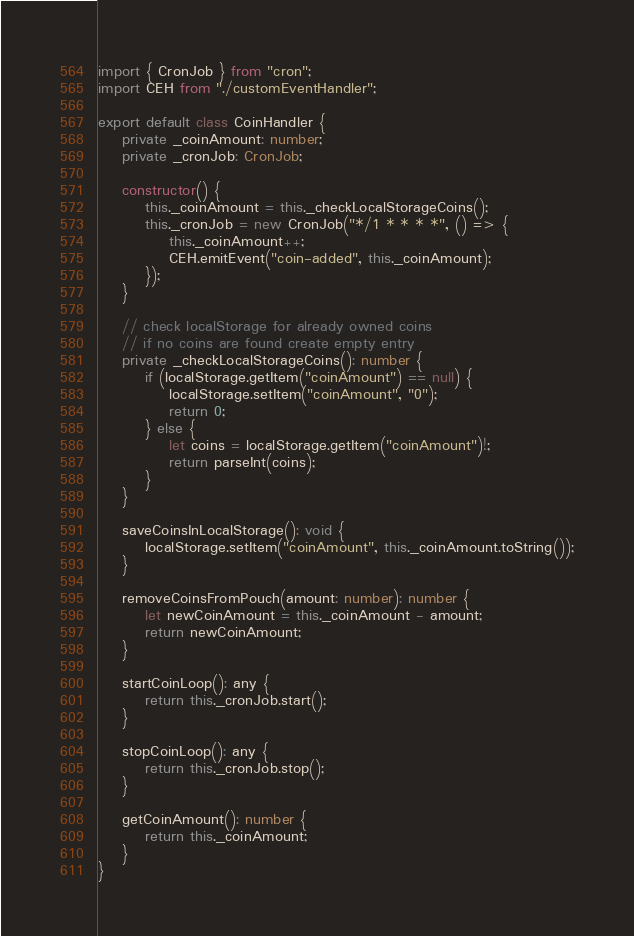<code> <loc_0><loc_0><loc_500><loc_500><_TypeScript_>import { CronJob } from "cron";
import CEH from "./customEventHandler";

export default class CoinHandler {
    private _coinAmount: number;
    private _cronJob: CronJob;

    constructor() {
        this._coinAmount = this._checkLocalStorageCoins();
        this._cronJob = new CronJob("*/1 * * * *", () => {
            this._coinAmount++;
            CEH.emitEvent("coin-added", this._coinAmount);
        });
    }

    // check localStorage for already owned coins
    // if no coins are found create empty entry
    private _checkLocalStorageCoins(): number {
        if (localStorage.getItem("coinAmount") == null) {
            localStorage.setItem("coinAmount", "0");
            return 0;
        } else {
            let coins = localStorage.getItem("coinAmount")!;
            return parseInt(coins);
        }
    }

    saveCoinsInLocalStorage(): void {
        localStorage.setItem("coinAmount", this._coinAmount.toString());
    }

    removeCoinsFromPouch(amount: number): number {
        let newCoinAmount = this._coinAmount - amount;
        return newCoinAmount;
    }

    startCoinLoop(): any {
        return this._cronJob.start();
    }

    stopCoinLoop(): any {
        return this._cronJob.stop();
    }

    getCoinAmount(): number {
        return this._coinAmount;
    }
}
</code> 